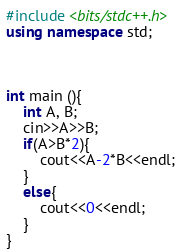Convert code to text. <code><loc_0><loc_0><loc_500><loc_500><_C++_>#include <bits/stdc++.h>
using namespace std;



int main (){
    int A, B;
    cin>>A>>B;
    if(A>B*2){
        cout<<A-2*B<<endl;
    }
    else{
        cout<<0<<endl;
    }
}</code> 